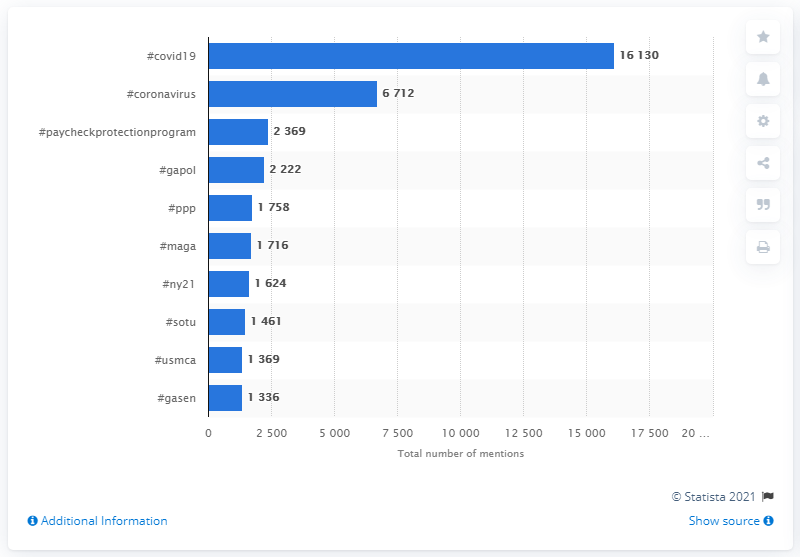Specify some key components in this picture. Republicans in Congress used the hashtag #covid19 as the most popular hashtag in 2020 to discuss the COVID-19 pandemic. 